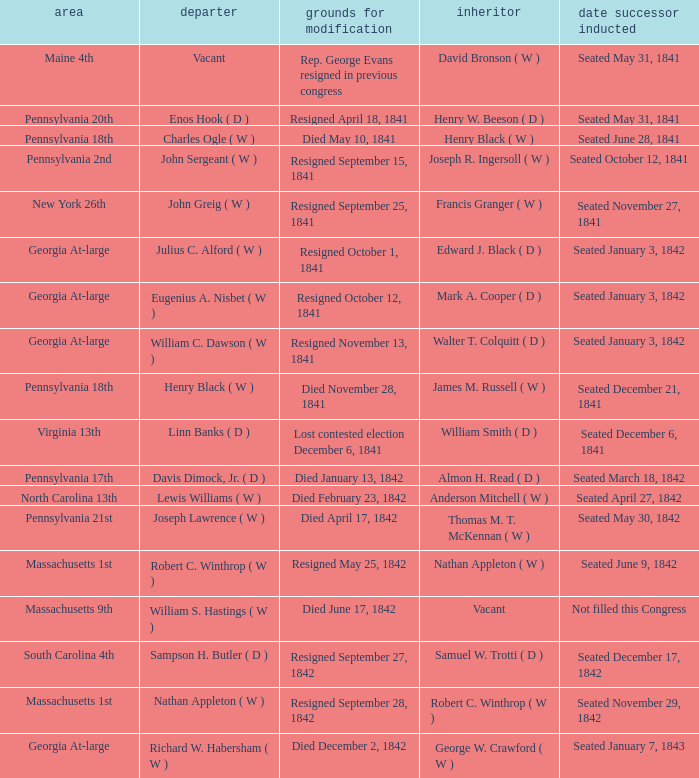Name the date successor seated for pennsylvania 17th Seated March 18, 1842. 